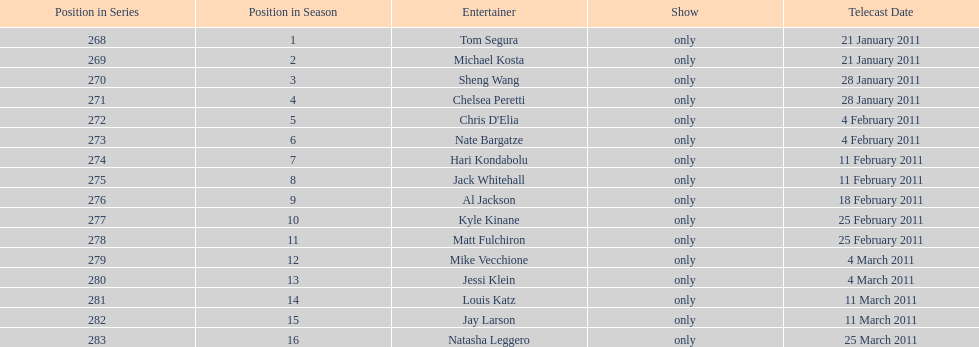Who appeared first tom segura or jay larson? Tom Segura. 